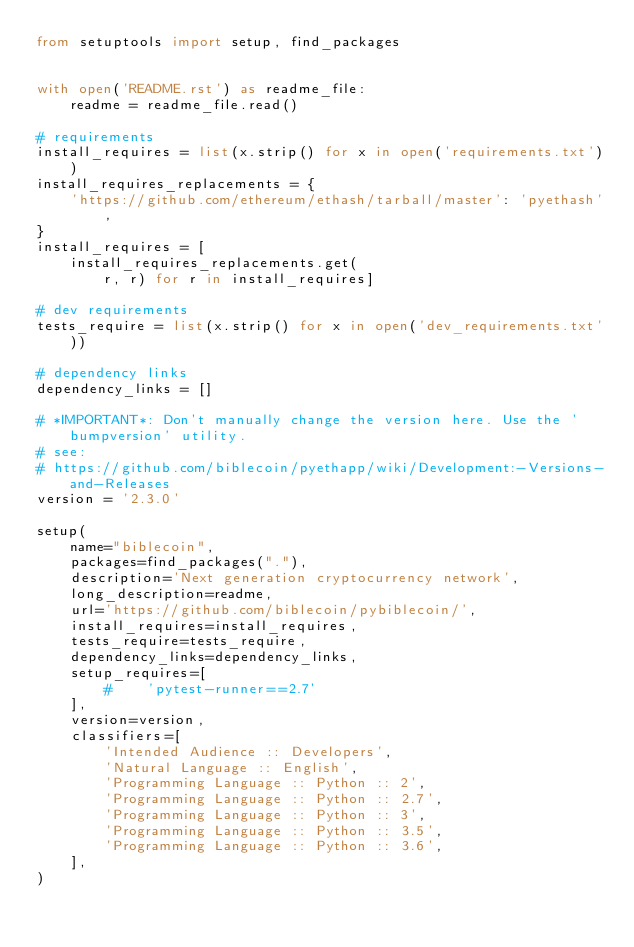<code> <loc_0><loc_0><loc_500><loc_500><_Python_>from setuptools import setup, find_packages


with open('README.rst') as readme_file:
    readme = readme_file.read()

# requirements
install_requires = list(x.strip() for x in open('requirements.txt'))
install_requires_replacements = {
    'https://github.com/ethereum/ethash/tarball/master': 'pyethash',
}
install_requires = [
    install_requires_replacements.get(
        r, r) for r in install_requires]

# dev requirements
tests_require = list(x.strip() for x in open('dev_requirements.txt'))

# dependency links
dependency_links = []

# *IMPORTANT*: Don't manually change the version here. Use the 'bumpversion' utility.
# see:
# https://github.com/biblecoin/pyethapp/wiki/Development:-Versions-and-Releases
version = '2.3.0'

setup(
    name="biblecoin",
    packages=find_packages("."),
    description='Next generation cryptocurrency network',
    long_description=readme,
    url='https://github.com/biblecoin/pybiblecoin/',
    install_requires=install_requires,
    tests_require=tests_require,
    dependency_links=dependency_links,
    setup_requires=[
        #    'pytest-runner==2.7'
    ],
    version=version,
    classifiers=[
        'Intended Audience :: Developers',
        'Natural Language :: English',
        'Programming Language :: Python :: 2',
        'Programming Language :: Python :: 2.7',
        'Programming Language :: Python :: 3',
        'Programming Language :: Python :: 3.5',
        'Programming Language :: Python :: 3.6',
    ],
)
</code> 